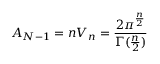<formula> <loc_0><loc_0><loc_500><loc_500>A _ { N - 1 } = n V _ { n } = \frac { 2 \pi ^ { \frac { n } { 2 } } } { \Gamma ( \frac { n } { 2 } ) }</formula> 